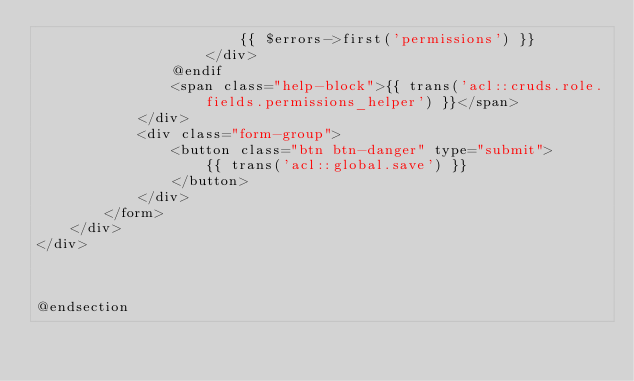Convert code to text. <code><loc_0><loc_0><loc_500><loc_500><_PHP_>                        {{ $errors->first('permissions') }}
                    </div>
                @endif
                <span class="help-block">{{ trans('acl::cruds.role.fields.permissions_helper') }}</span>
            </div>
            <div class="form-group">
                <button class="btn btn-danger" type="submit">
                    {{ trans('acl::global.save') }}
                </button>
            </div>
        </form>
    </div>
</div>



@endsection</code> 